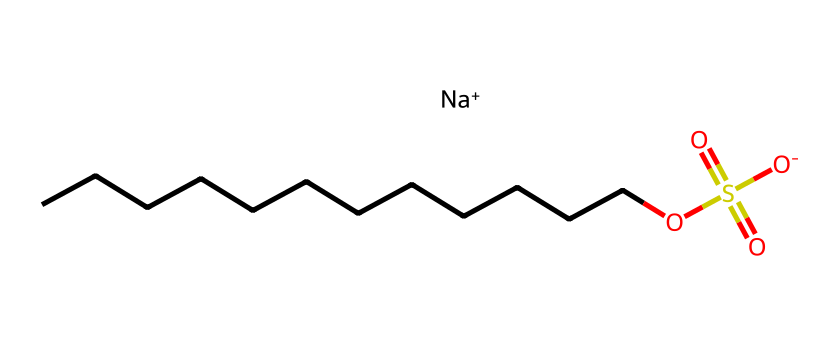What is the molecular formula of sodium lauryl sulfate? The SMILES representation indicates the presence of 12 carbon (C) atoms, 26 hydrogen (H) atoms, 1 sulfur (S) atom, and 4 oxygen (O) atoms. Thus, by counting, we can derive the molecular formula, which is C12H25NaO4S.
Answer: C12H25NaO4S How many carbon atoms are present in sodium lauryl sulfate? From the SMILES representation, we can observe that there are 12 carbon atoms (CCCCCCCCCCCC), as each 'C' in the chain represents one carbon atom.
Answer: 12 What type of ion is represented by "[Na+]" in this structure? The "[Na+]" part of the SMILES signifies a positively charged sodium ion, indicating that sodium is present in its ionic form, which is a cation.
Answer: cation How many oxygen atoms are in the sulfate group? In the SMILES representation, the sulfate group consists of the part "OS(=O)(=O)", indicating there are three oxygen atoms bonded to the sulfur atom and one oxygen in the form of an anionic bond with the sodium, making a total of four oxygen atoms in the sulfate group.
Answer: 4 What role does the long carbon chain play in sodium lauryl sulfate? The long carbon chain (CCCCCCCCCCCC) provides hydrophobic properties, which allow the molecule to interact with oils and grease, enabling its function as a surfactant and detergent by reducing surface tension.
Answer: hydrophobic properties What type of surfactant is sodium lauryl sulfate classified as? Given that sodium lauryl sulfate contains a negatively charged sulfate group, it is categorized as an anionic surfactant, which is characterized by its ability to carry a negative charge in solutions.
Answer: anionic What is the primary function of sodium lauryl sulfate in cleaning products? Sodium lauryl sulfate acts primarily to reduce surface tension, allowing it to emulsify oils and dirt, which aids in removing them during washing.
Answer: emulsifier 